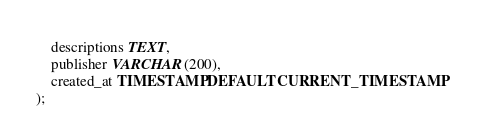Convert code to text. <code><loc_0><loc_0><loc_500><loc_500><_SQL_>    descriptions TEXT,
    publisher VARCHAR(200),
    created_at TIMESTAMP DEFAULT CURRENT_TIMESTAMP
);</code> 